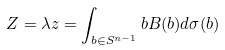Convert formula to latex. <formula><loc_0><loc_0><loc_500><loc_500>Z = \lambda z = \int _ { b \in S ^ { n - 1 } } { b B ( b ) d \sigma ( b ) }</formula> 